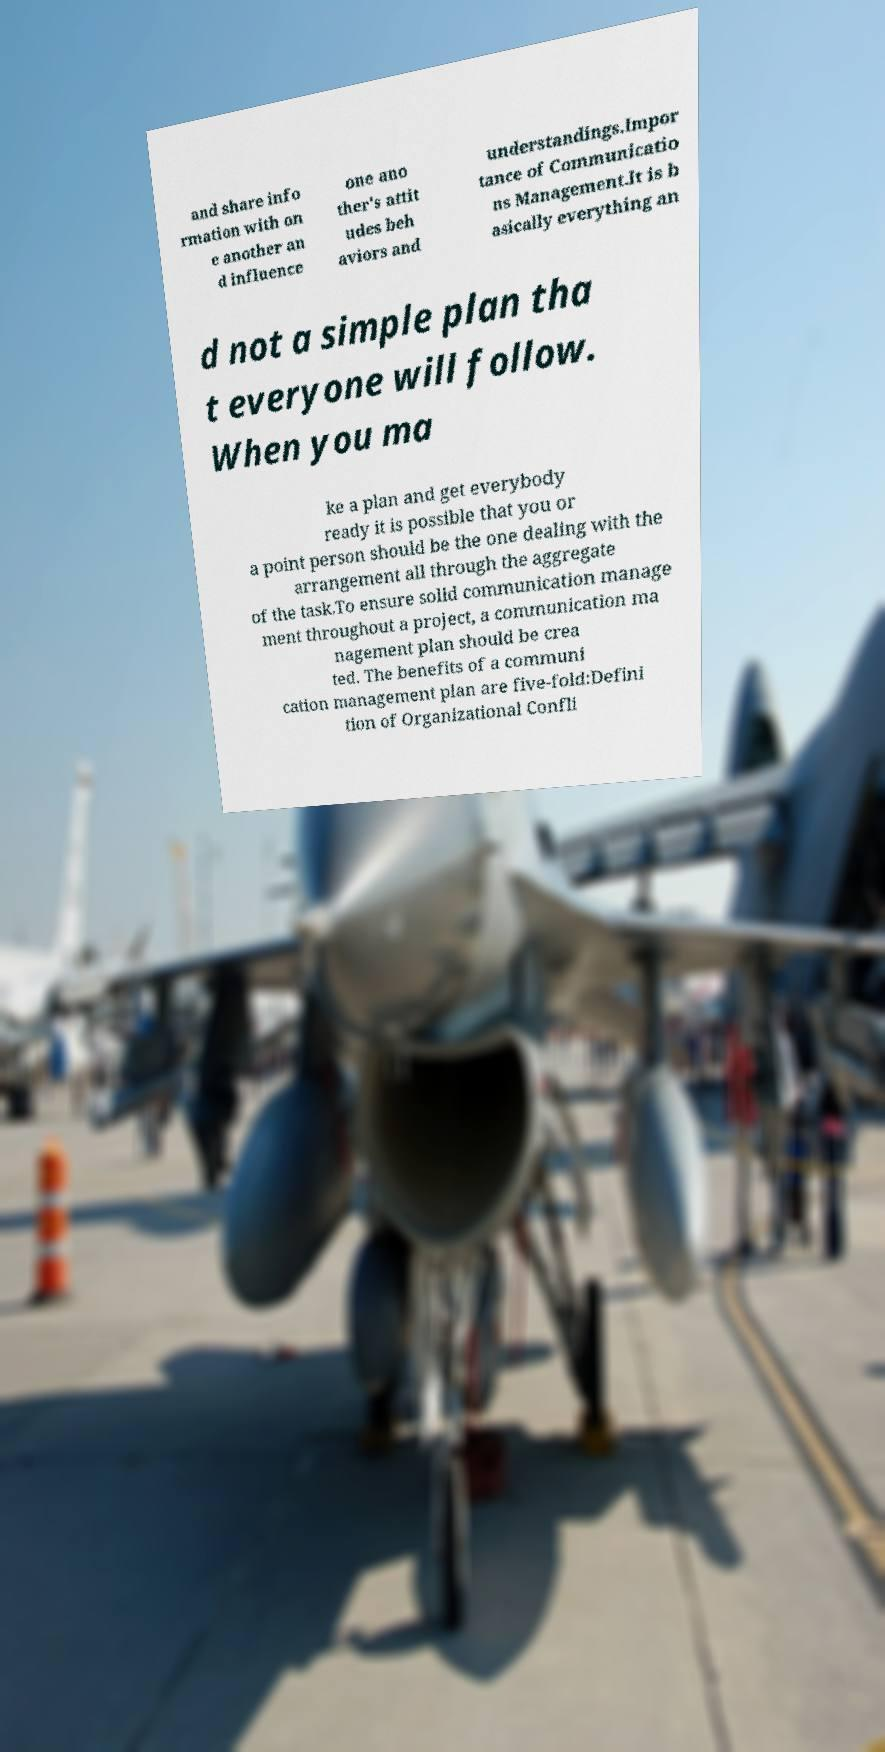What messages or text are displayed in this image? I need them in a readable, typed format. and share info rmation with on e another an d influence one ano ther's attit udes beh aviors and understandings.Impor tance of Communicatio ns Management.It is b asically everything an d not a simple plan tha t everyone will follow. When you ma ke a plan and get everybody ready it is possible that you or a point person should be the one dealing with the arrangement all through the aggregate of the task.To ensure solid communication manage ment throughout a project, a communication ma nagement plan should be crea ted. The benefits of a communi cation management plan are five-fold:Defini tion of Organizational Confli 